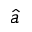Convert formula to latex. <formula><loc_0><loc_0><loc_500><loc_500>\hat { a }</formula> 